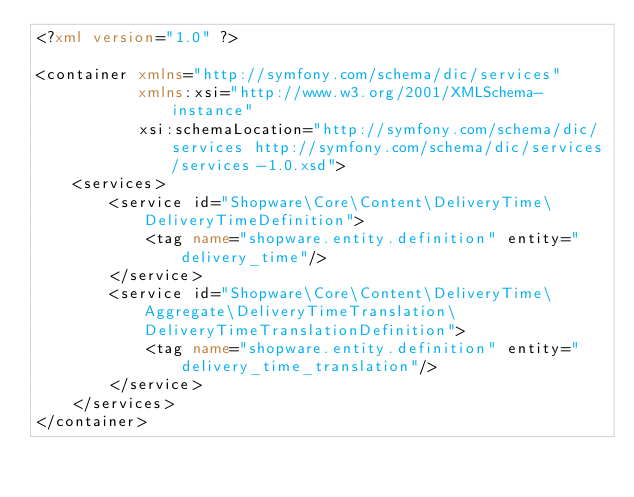Convert code to text. <code><loc_0><loc_0><loc_500><loc_500><_XML_><?xml version="1.0" ?>

<container xmlns="http://symfony.com/schema/dic/services"
           xmlns:xsi="http://www.w3.org/2001/XMLSchema-instance"
           xsi:schemaLocation="http://symfony.com/schema/dic/services http://symfony.com/schema/dic/services/services-1.0.xsd">
    <services>
        <service id="Shopware\Core\Content\DeliveryTime\DeliveryTimeDefinition">
            <tag name="shopware.entity.definition" entity="delivery_time"/>
        </service>
        <service id="Shopware\Core\Content\DeliveryTime\Aggregate\DeliveryTimeTranslation\DeliveryTimeTranslationDefinition">
            <tag name="shopware.entity.definition" entity="delivery_time_translation"/>
        </service>
    </services>
</container>
</code> 